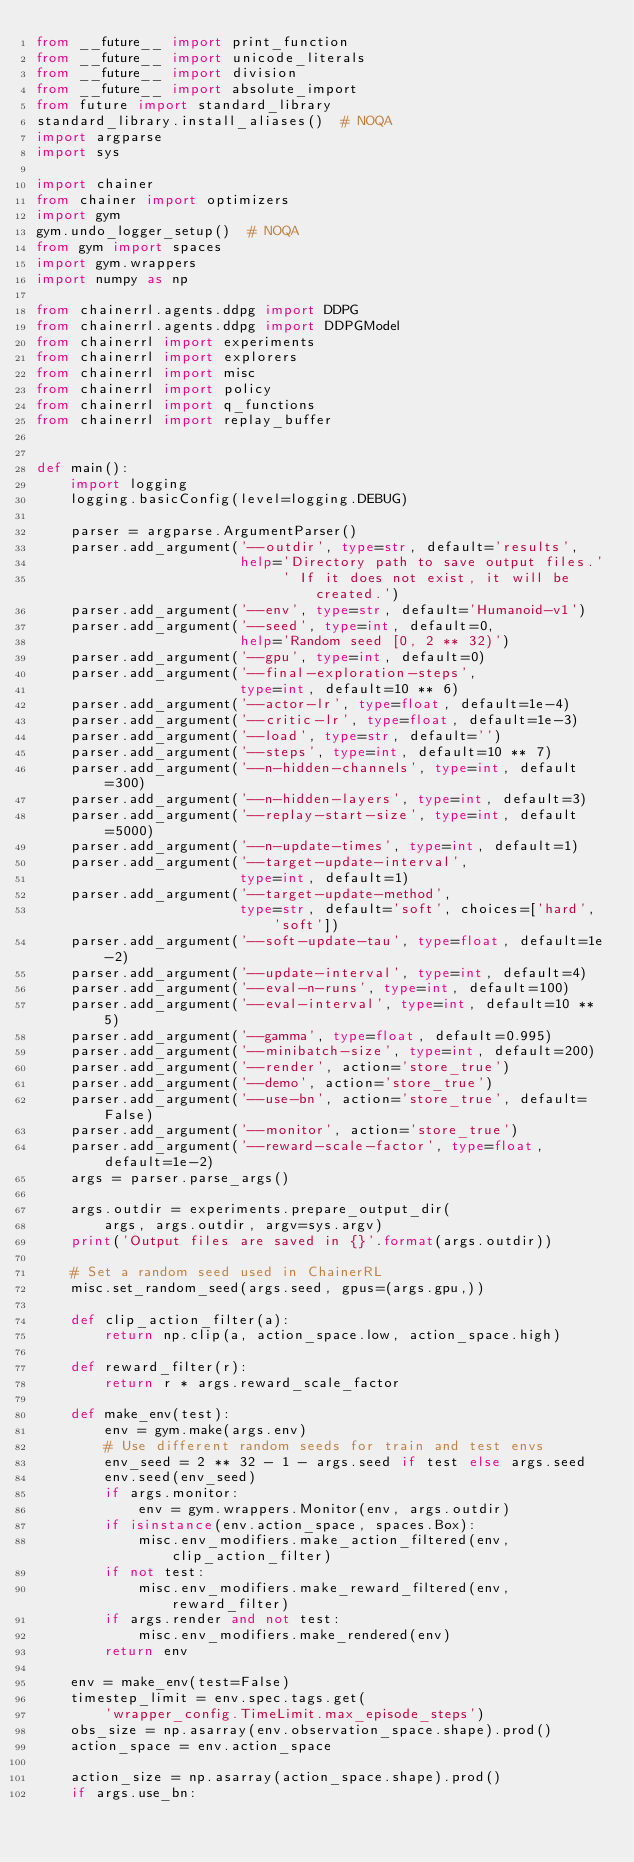Convert code to text. <code><loc_0><loc_0><loc_500><loc_500><_Python_>from __future__ import print_function
from __future__ import unicode_literals
from __future__ import division
from __future__ import absolute_import
from future import standard_library
standard_library.install_aliases()  # NOQA
import argparse
import sys

import chainer
from chainer import optimizers
import gym
gym.undo_logger_setup()  # NOQA
from gym import spaces
import gym.wrappers
import numpy as np

from chainerrl.agents.ddpg import DDPG
from chainerrl.agents.ddpg import DDPGModel
from chainerrl import experiments
from chainerrl import explorers
from chainerrl import misc
from chainerrl import policy
from chainerrl import q_functions
from chainerrl import replay_buffer


def main():
    import logging
    logging.basicConfig(level=logging.DEBUG)

    parser = argparse.ArgumentParser()
    parser.add_argument('--outdir', type=str, default='results',
                        help='Directory path to save output files.'
                             ' If it does not exist, it will be created.')
    parser.add_argument('--env', type=str, default='Humanoid-v1')
    parser.add_argument('--seed', type=int, default=0,
                        help='Random seed [0, 2 ** 32)')
    parser.add_argument('--gpu', type=int, default=0)
    parser.add_argument('--final-exploration-steps',
                        type=int, default=10 ** 6)
    parser.add_argument('--actor-lr', type=float, default=1e-4)
    parser.add_argument('--critic-lr', type=float, default=1e-3)
    parser.add_argument('--load', type=str, default='')
    parser.add_argument('--steps', type=int, default=10 ** 7)
    parser.add_argument('--n-hidden-channels', type=int, default=300)
    parser.add_argument('--n-hidden-layers', type=int, default=3)
    parser.add_argument('--replay-start-size', type=int, default=5000)
    parser.add_argument('--n-update-times', type=int, default=1)
    parser.add_argument('--target-update-interval',
                        type=int, default=1)
    parser.add_argument('--target-update-method',
                        type=str, default='soft', choices=['hard', 'soft'])
    parser.add_argument('--soft-update-tau', type=float, default=1e-2)
    parser.add_argument('--update-interval', type=int, default=4)
    parser.add_argument('--eval-n-runs', type=int, default=100)
    parser.add_argument('--eval-interval', type=int, default=10 ** 5)
    parser.add_argument('--gamma', type=float, default=0.995)
    parser.add_argument('--minibatch-size', type=int, default=200)
    parser.add_argument('--render', action='store_true')
    parser.add_argument('--demo', action='store_true')
    parser.add_argument('--use-bn', action='store_true', default=False)
    parser.add_argument('--monitor', action='store_true')
    parser.add_argument('--reward-scale-factor', type=float, default=1e-2)
    args = parser.parse_args()

    args.outdir = experiments.prepare_output_dir(
        args, args.outdir, argv=sys.argv)
    print('Output files are saved in {}'.format(args.outdir))

    # Set a random seed used in ChainerRL
    misc.set_random_seed(args.seed, gpus=(args.gpu,))

    def clip_action_filter(a):
        return np.clip(a, action_space.low, action_space.high)

    def reward_filter(r):
        return r * args.reward_scale_factor

    def make_env(test):
        env = gym.make(args.env)
        # Use different random seeds for train and test envs
        env_seed = 2 ** 32 - 1 - args.seed if test else args.seed
        env.seed(env_seed)
        if args.monitor:
            env = gym.wrappers.Monitor(env, args.outdir)
        if isinstance(env.action_space, spaces.Box):
            misc.env_modifiers.make_action_filtered(env, clip_action_filter)
        if not test:
            misc.env_modifiers.make_reward_filtered(env, reward_filter)
        if args.render and not test:
            misc.env_modifiers.make_rendered(env)
        return env

    env = make_env(test=False)
    timestep_limit = env.spec.tags.get(
        'wrapper_config.TimeLimit.max_episode_steps')
    obs_size = np.asarray(env.observation_space.shape).prod()
    action_space = env.action_space

    action_size = np.asarray(action_space.shape).prod()
    if args.use_bn:</code> 